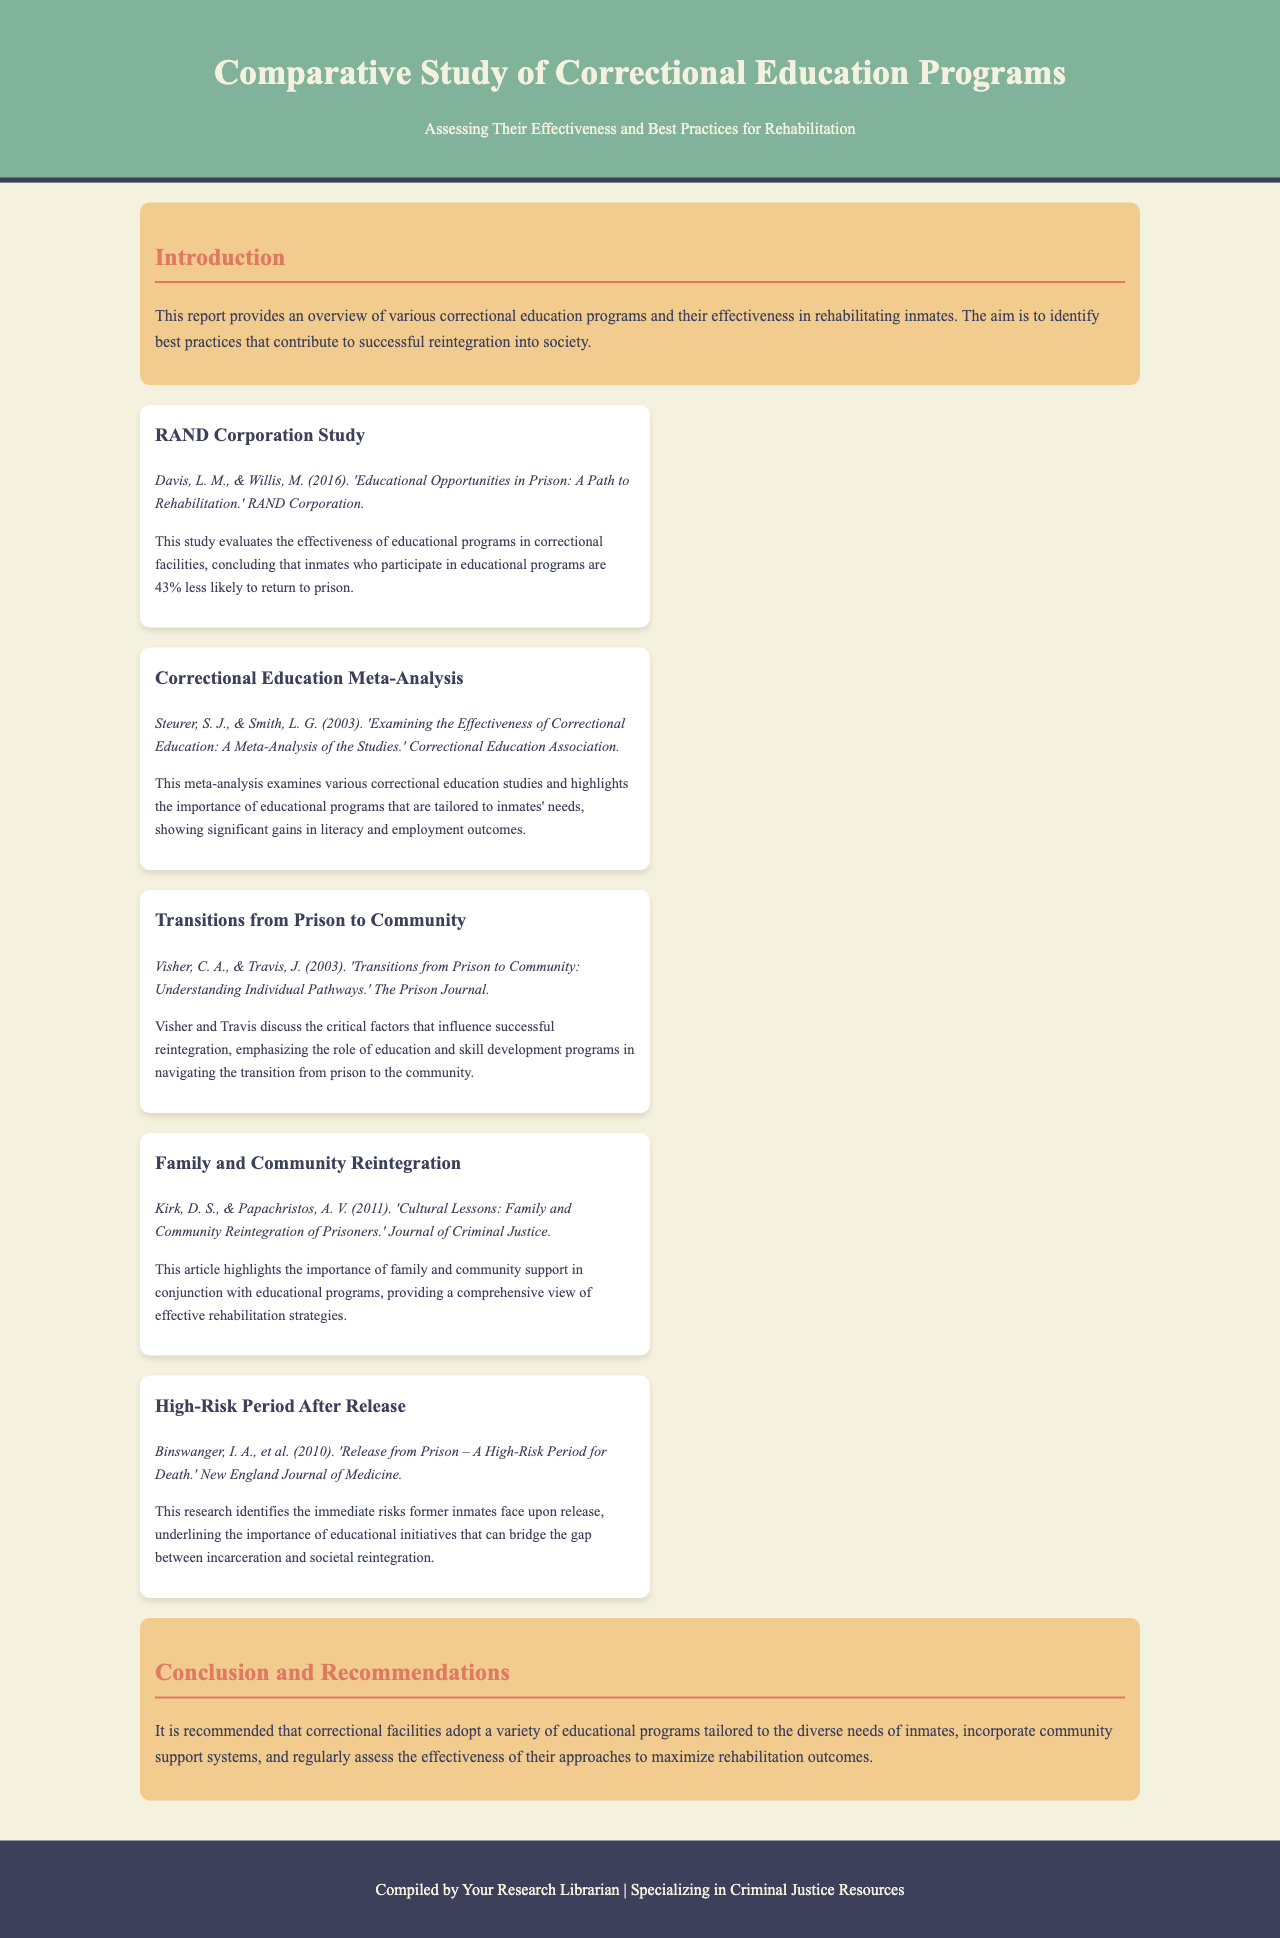What is the title of the report? The title is clearly stated in the header section of the document.
Answer: Comparative Study of Correctional Education Programs Who are the authors of the RAND Corporation Study? The authors are listed under the material section for the RAND Corporation Study.
Answer: Davis, L. M., & Willis, M What percentage less likely are inmates to return to prison if they participate in educational programs, according to the RAND Corporation Study? The specific statistic regarding return rates is given in the summary of the RAND Corporation Study.
Answer: 43% Which publication examines the effectiveness of correctional education through a meta-analysis? The title of the publication is mentioned in the corresponding material section.
Answer: Correctional Education Meta-Analysis What is emphasized as a critical factor for successful reintegration from prison, as noted by Visher and Travis? This factor is highlighted in the discussion provided in the Transitions from Prison to Community material.
Answer: Education and skill development programs According to the conclusion, what should correctional facilities incorporate to maximize rehabilitation outcomes? The recommendations in the conclusion detail the necessary components for effective rehabilitation.
Answer: Community support systems What year was the study by Binswanger et al. published? The publication year is provided with the citation in the material section for the High-Risk Period After Release.
Answer: 2010 What is the main aim of the report as stated in the introduction? The aim of the report is outlined succinctly in the introduction section.
Answer: Identify best practices for rehabilitation 